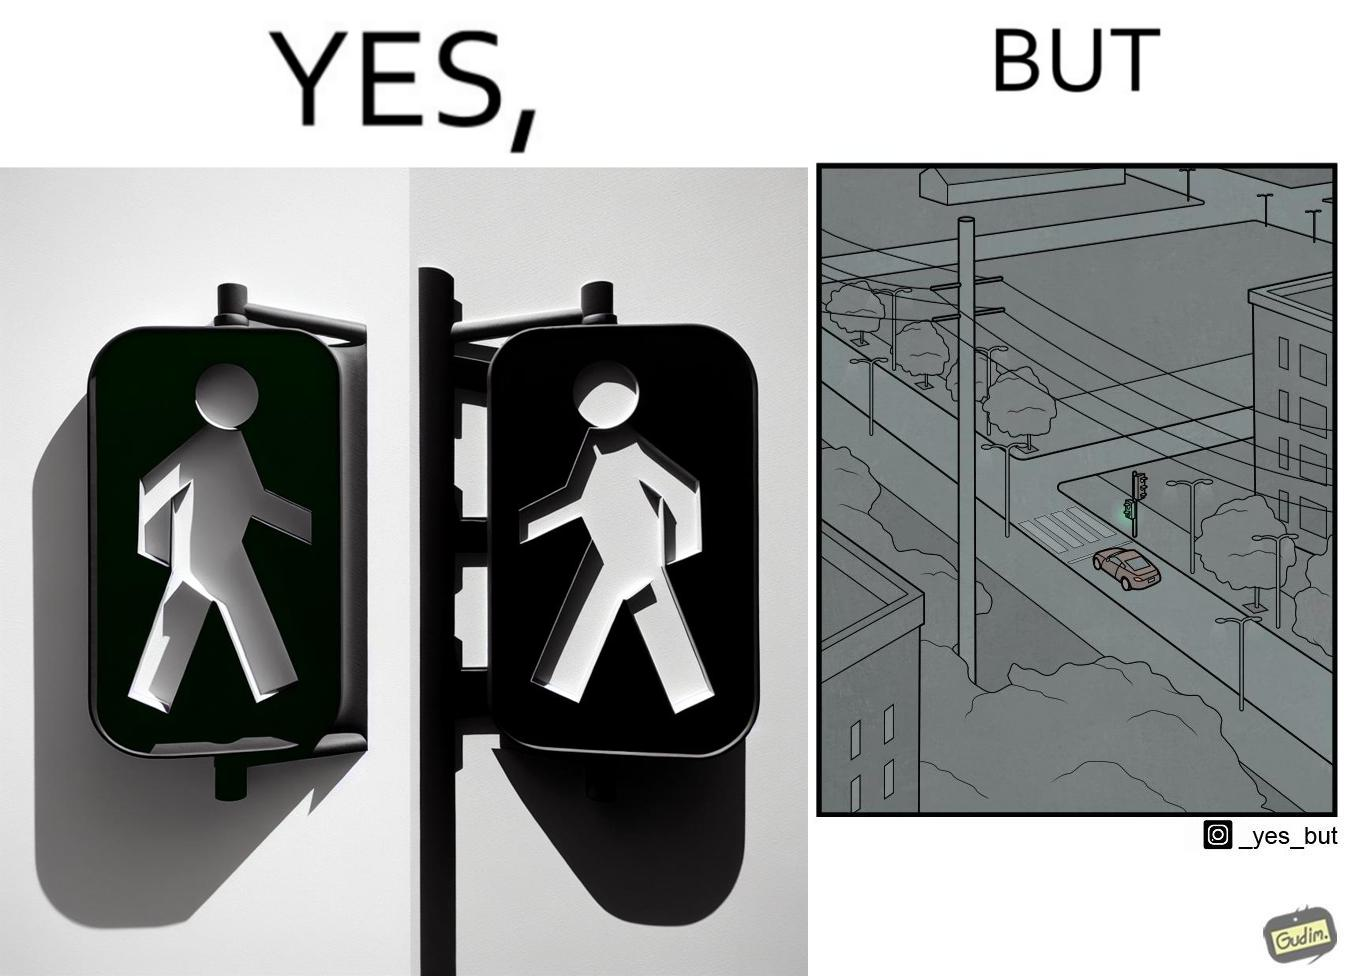What makes this image funny or satirical? The image is funny because while walk signs are very useful for pedestrians to be able to cross roads safely, the become unnecessary and annoying for car drivers when these signals turn green even when there is no pedestrian tring to cross the road. 